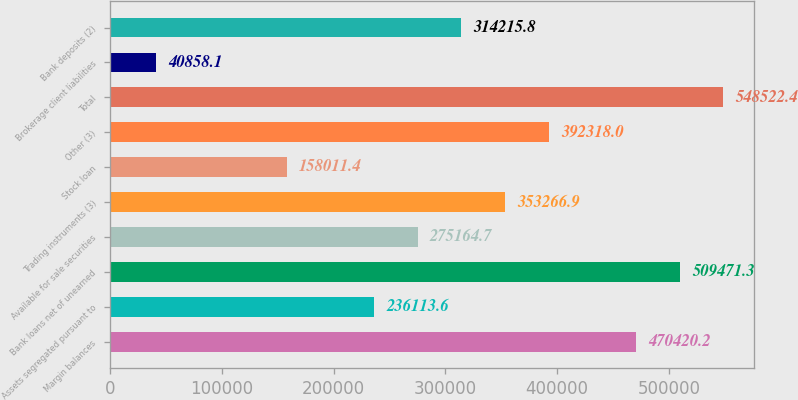Convert chart. <chart><loc_0><loc_0><loc_500><loc_500><bar_chart><fcel>Margin balances<fcel>Assets segregated pursuant to<fcel>Bank loans net of unearned<fcel>Available for sale securities<fcel>Trading instruments (3)<fcel>Stock loan<fcel>Other (3)<fcel>Total<fcel>Brokerage client liabilities<fcel>Bank deposits (2)<nl><fcel>470420<fcel>236114<fcel>509471<fcel>275165<fcel>353267<fcel>158011<fcel>392318<fcel>548522<fcel>40858.1<fcel>314216<nl></chart> 